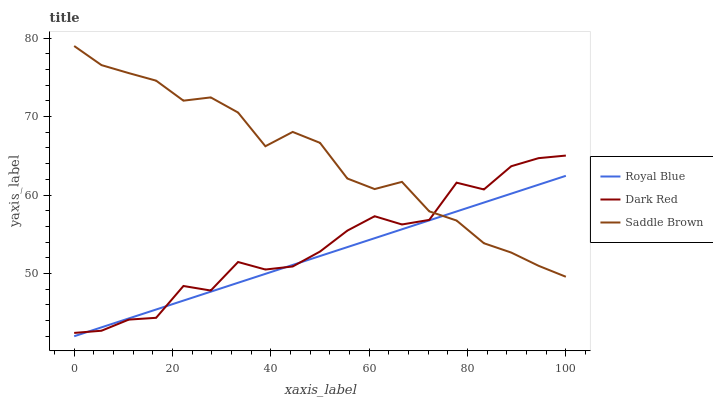Does Royal Blue have the minimum area under the curve?
Answer yes or no. Yes. Does Saddle Brown have the maximum area under the curve?
Answer yes or no. Yes. Does Dark Red have the minimum area under the curve?
Answer yes or no. No. Does Dark Red have the maximum area under the curve?
Answer yes or no. No. Is Royal Blue the smoothest?
Answer yes or no. Yes. Is Dark Red the roughest?
Answer yes or no. Yes. Is Saddle Brown the smoothest?
Answer yes or no. No. Is Saddle Brown the roughest?
Answer yes or no. No. Does Royal Blue have the lowest value?
Answer yes or no. Yes. Does Dark Red have the lowest value?
Answer yes or no. No. Does Saddle Brown have the highest value?
Answer yes or no. Yes. Does Dark Red have the highest value?
Answer yes or no. No. Does Saddle Brown intersect Royal Blue?
Answer yes or no. Yes. Is Saddle Brown less than Royal Blue?
Answer yes or no. No. Is Saddle Brown greater than Royal Blue?
Answer yes or no. No. 